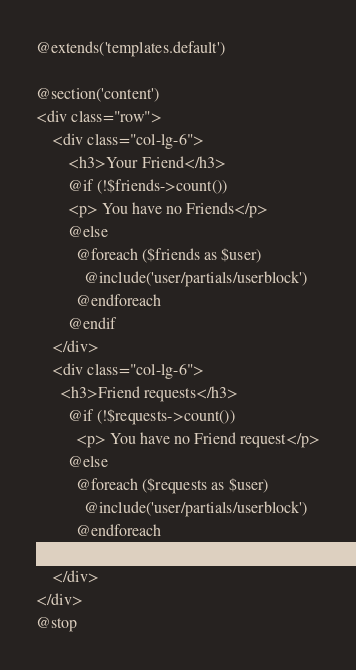Convert code to text. <code><loc_0><loc_0><loc_500><loc_500><_PHP_>@extends('templates.default')

@section('content')
<div class="row">
    <div class="col-lg-6">
        <h3>Your Friend</h3>
        @if (!$friends->count())
        <p> You have no Friends</p>
        @else
          @foreach ($friends as $user)
            @include('user/partials/userblock')
          @endforeach
        @endif
    </div>
    <div class="col-lg-6">
      <h3>Friend requests</h3>
        @if (!$requests->count())
          <p> You have no Friend request</p>
        @else
          @foreach ($requests as $user)
            @include('user/partials/userblock')
          @endforeach
        @endif
    </div>
</div>
@stop
</code> 